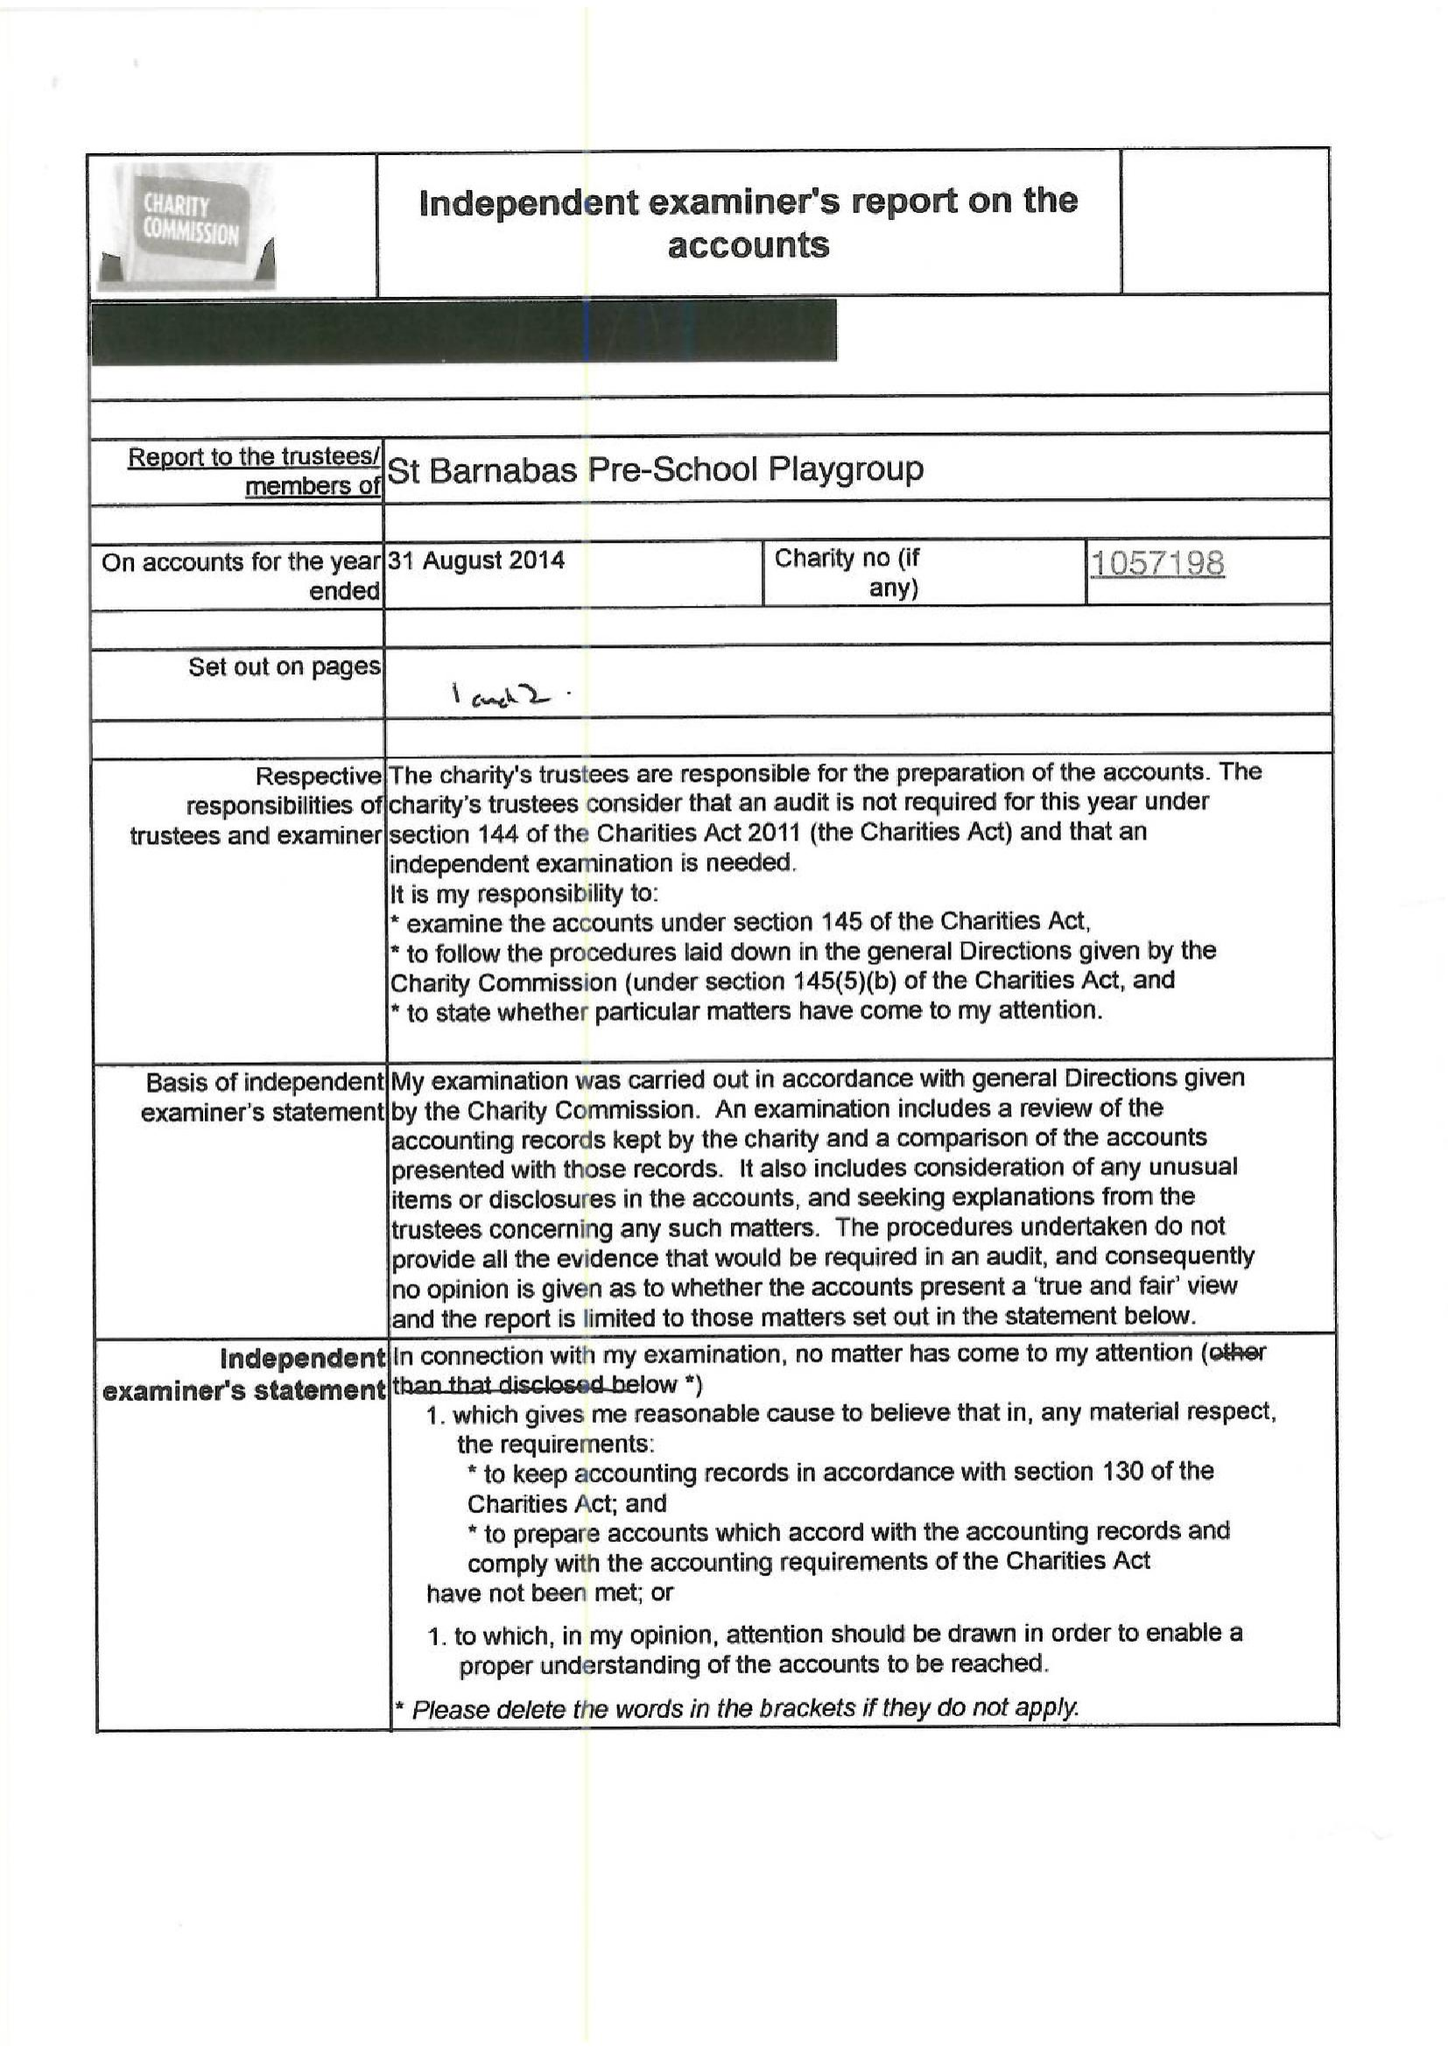What is the value for the spending_annually_in_british_pounds?
Answer the question using a single word or phrase. 54930.00 